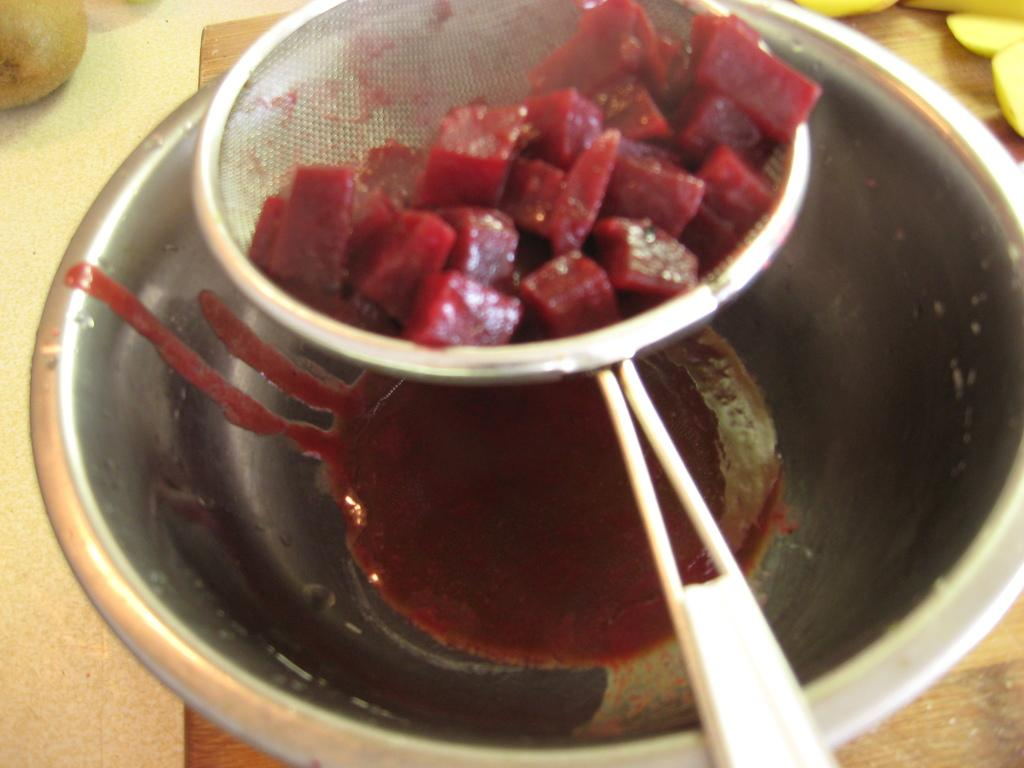What is on the strainer in the image? There are beetroot pieces on a strainer in the image. What is contained in the bowl in the image? There is juice in a bowl in the image. What other items can be seen on the table in the image? There are other fruits on the table in the image. Is there a volleyball game happening on the table in the image? No, there is no volleyball game or any reference to a volleyball in the image. 